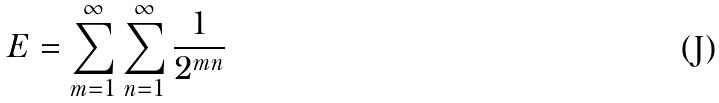Convert formula to latex. <formula><loc_0><loc_0><loc_500><loc_500>E = \sum _ { m = 1 } ^ { \infty } \sum _ { n = 1 } ^ { \infty } \frac { 1 } { 2 ^ { m n } }</formula> 